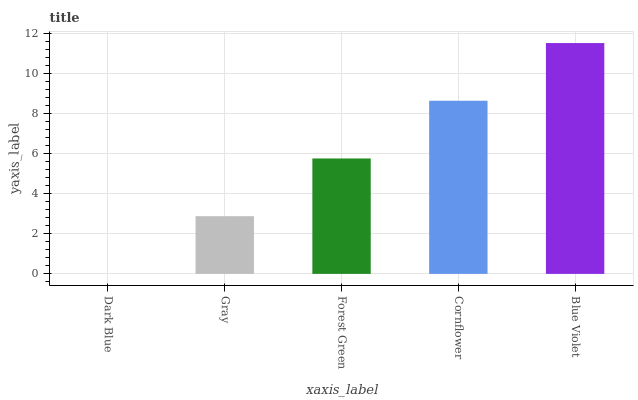Is Dark Blue the minimum?
Answer yes or no. Yes. Is Blue Violet the maximum?
Answer yes or no. Yes. Is Gray the minimum?
Answer yes or no. No. Is Gray the maximum?
Answer yes or no. No. Is Gray greater than Dark Blue?
Answer yes or no. Yes. Is Dark Blue less than Gray?
Answer yes or no. Yes. Is Dark Blue greater than Gray?
Answer yes or no. No. Is Gray less than Dark Blue?
Answer yes or no. No. Is Forest Green the high median?
Answer yes or no. Yes. Is Forest Green the low median?
Answer yes or no. Yes. Is Cornflower the high median?
Answer yes or no. No. Is Dark Blue the low median?
Answer yes or no. No. 